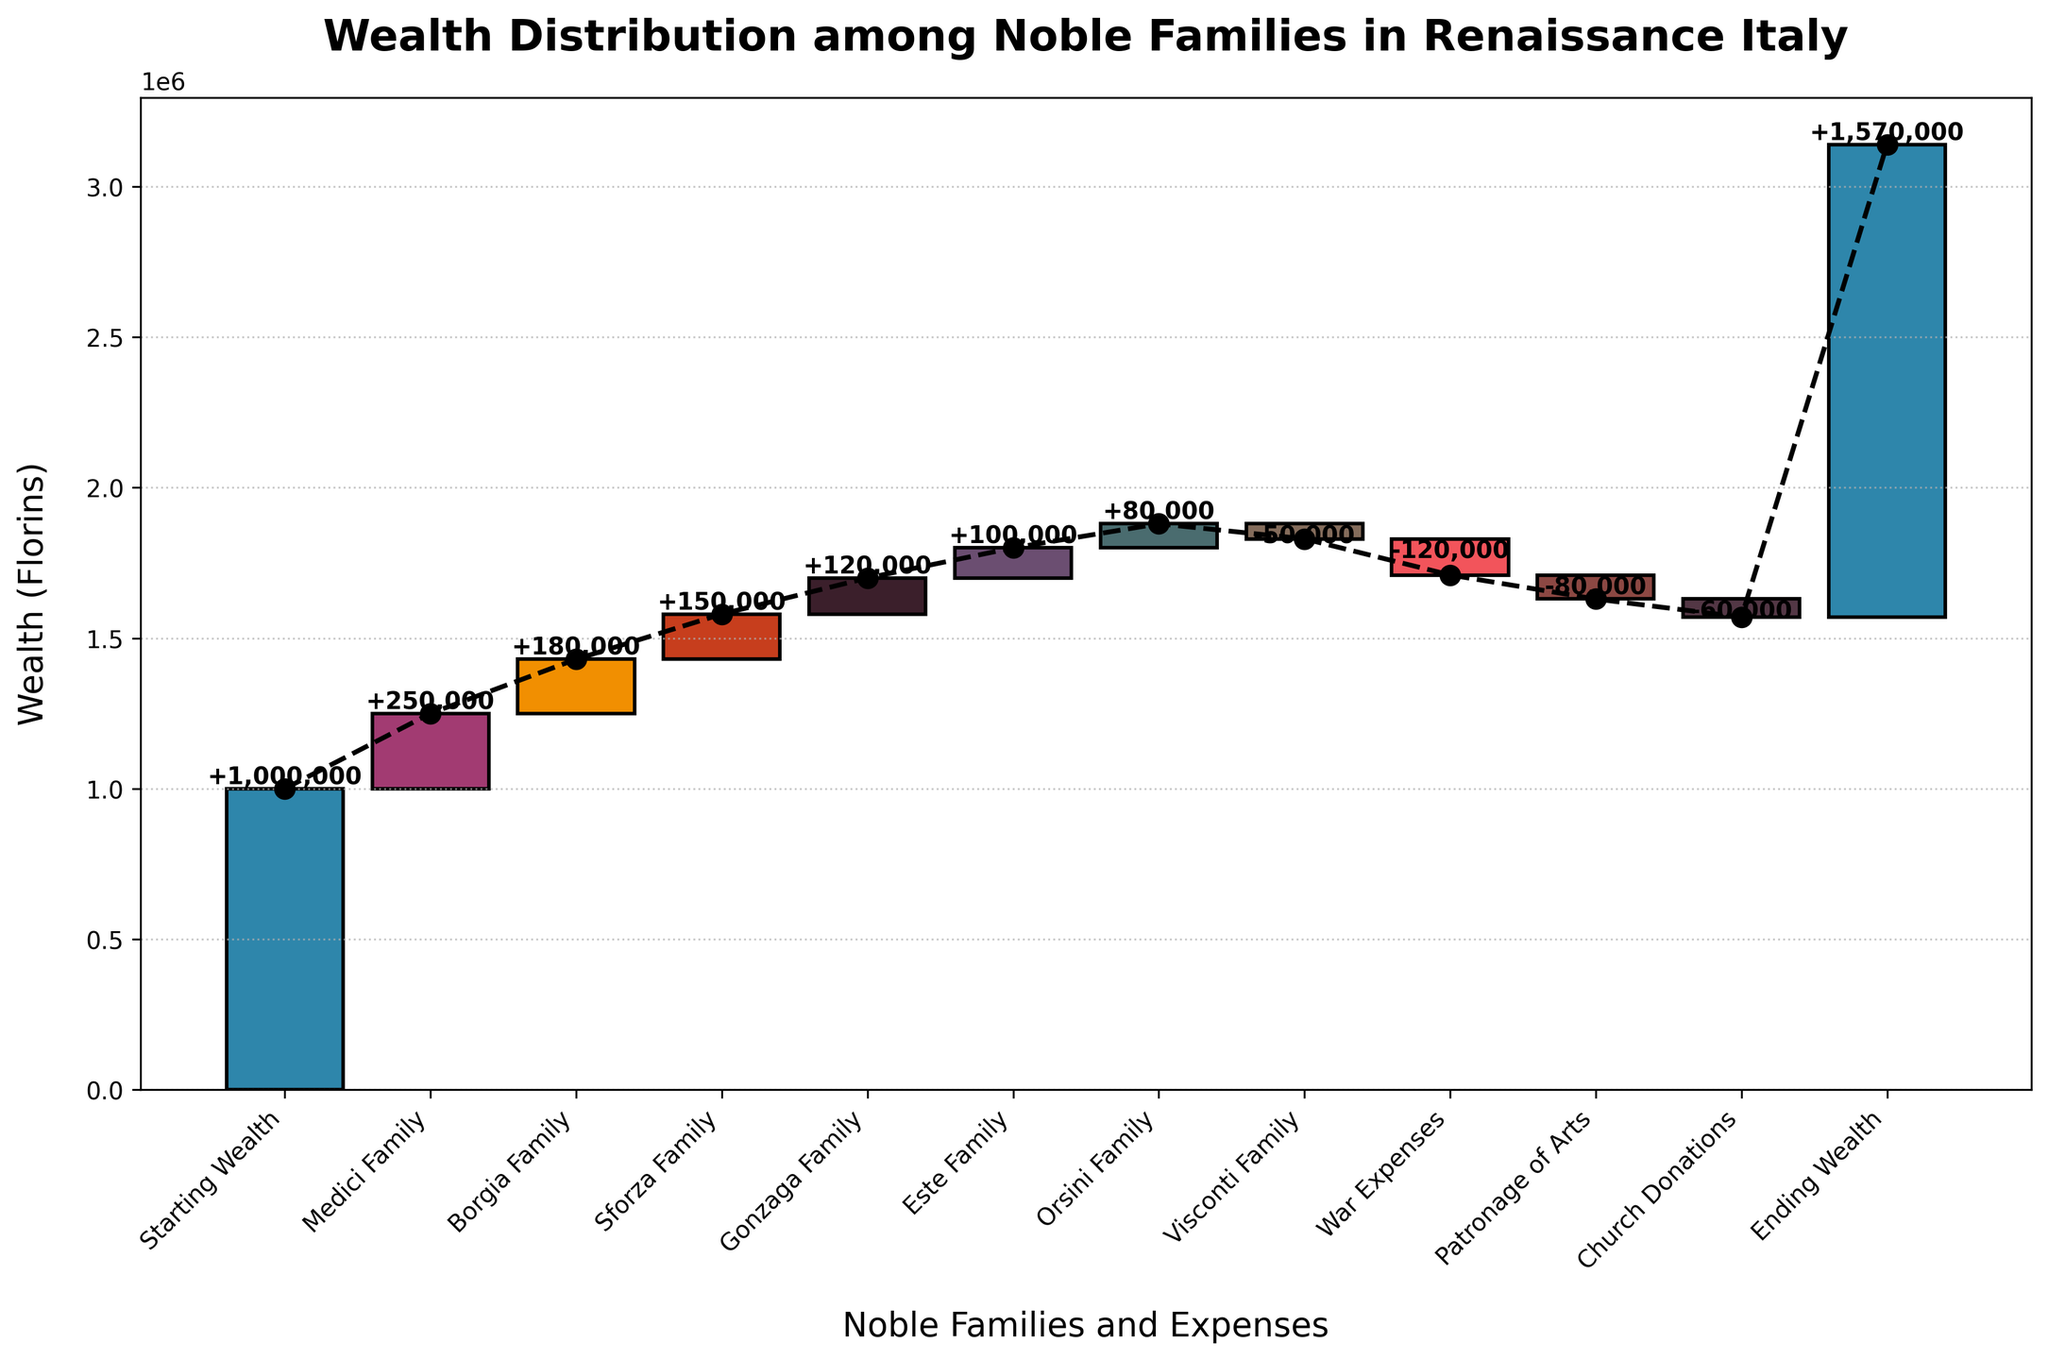what is the title of the figure? The title of the figure is typically found at the top of the chart. It helps to understand what the chart is about at a glance.
Answer: Wealth Distribution among Noble Families in Renaissance Italy What does the vertical axis represent? The vertical axis typically represents the main variable being measured. In this chart, it indicates the wealth measured in florins.
Answer: Wealth (Florins) Which family contributed the highest amount of wealth? Look at the bar heights and the labels. The tallest positive bar represents the highest contribution. The Medici family has the highest bar.
Answer: Medici Family By how much did the wealth increase or decrease due to war expenses? Identify the bar labeled "War Expenses" and read its value. War Expenses have a negative value of -120,000 florins.
Answer: -120,000 florins What is the total wealth gained from all noble families combined (Medici to Visconti)? Sum the positive contributions from Medici, Borgia, Sforza, Gonzaga, Este, Orsini, and Visconti families: 250,000 + 180,000 + 150,000 + 120,000 + 100,000 + 80,000 - 50,000 = 830,000
Answer: 830,000 Which expense had the least negative impact on the wealth? Among the entries with negative values, compare their magnitudes. Church Donations had the smallest negative value of -60,000 florins.
Answer: Church Donations What is the difference in wealth contribution between the Medici family and the Orsini family? Subtract the wealth contribution of the Orsini family from that of the Medici family: 250,000 - 80,000 = 170,000
Answer: 170,000 What is the final ending wealth as shown in the chart? The final ending wealth is displayed at the far right of the chart. It’s labeled as "Ending Wealth" and equals 1,570,000 florins.
Answer: 1,570,000 florins How much did the total wealth change due to patronage of arts and church donations together? Add the negative impacts of these two categories: -80,000 + -60,000 = -140,000
Answer: -140,000 Comparing the increments from all the noble families, which two have the closest contributions? Look at the positive bars from Medici, Borgia, Sforza, Gonzaga, Este, Orsini, Visconti. The Gonzaga and Este families have contributions of 120,000 and 100,000 respectively, a difference of 20,000.
Answer: Gonzaga and Este Families 